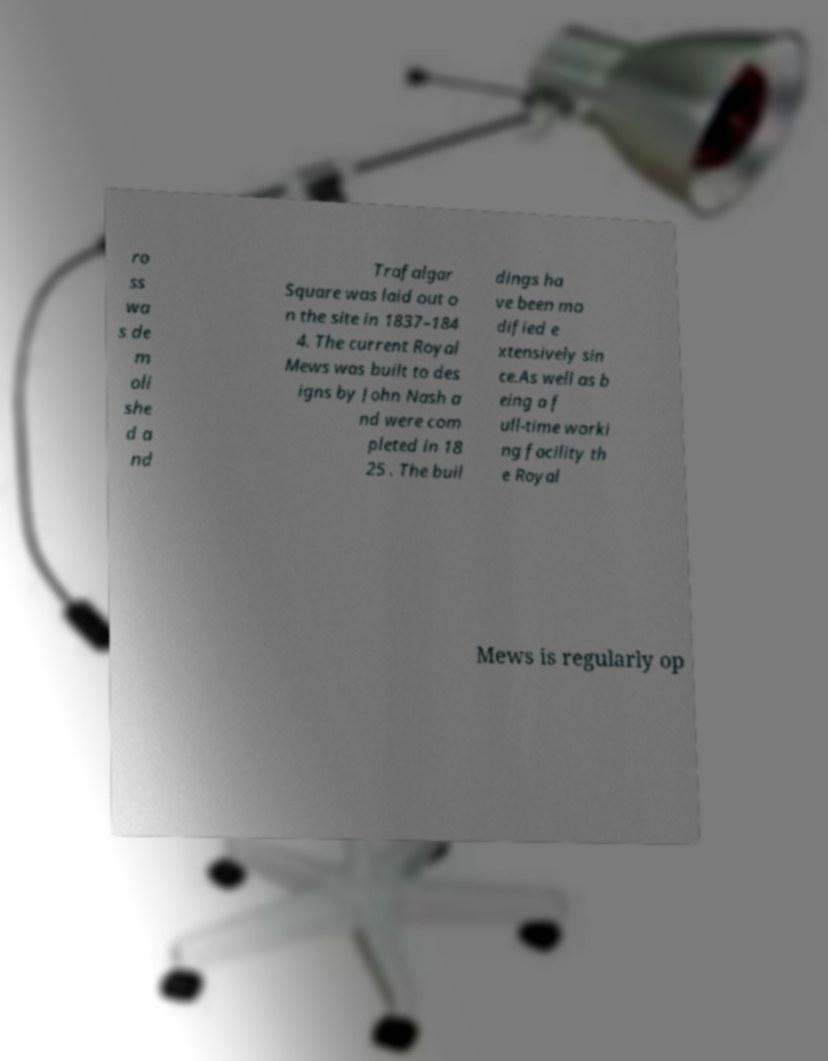I need the written content from this picture converted into text. Can you do that? ro ss wa s de m oli she d a nd Trafalgar Square was laid out o n the site in 1837–184 4. The current Royal Mews was built to des igns by John Nash a nd were com pleted in 18 25 . The buil dings ha ve been mo dified e xtensively sin ce.As well as b eing a f ull-time worki ng facility th e Royal Mews is regularly op 